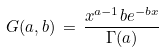Convert formula to latex. <formula><loc_0><loc_0><loc_500><loc_500>G ( a , b ) \, = \, \frac { x ^ { a - 1 } b e ^ { - b x } } { \Gamma ( a ) }</formula> 